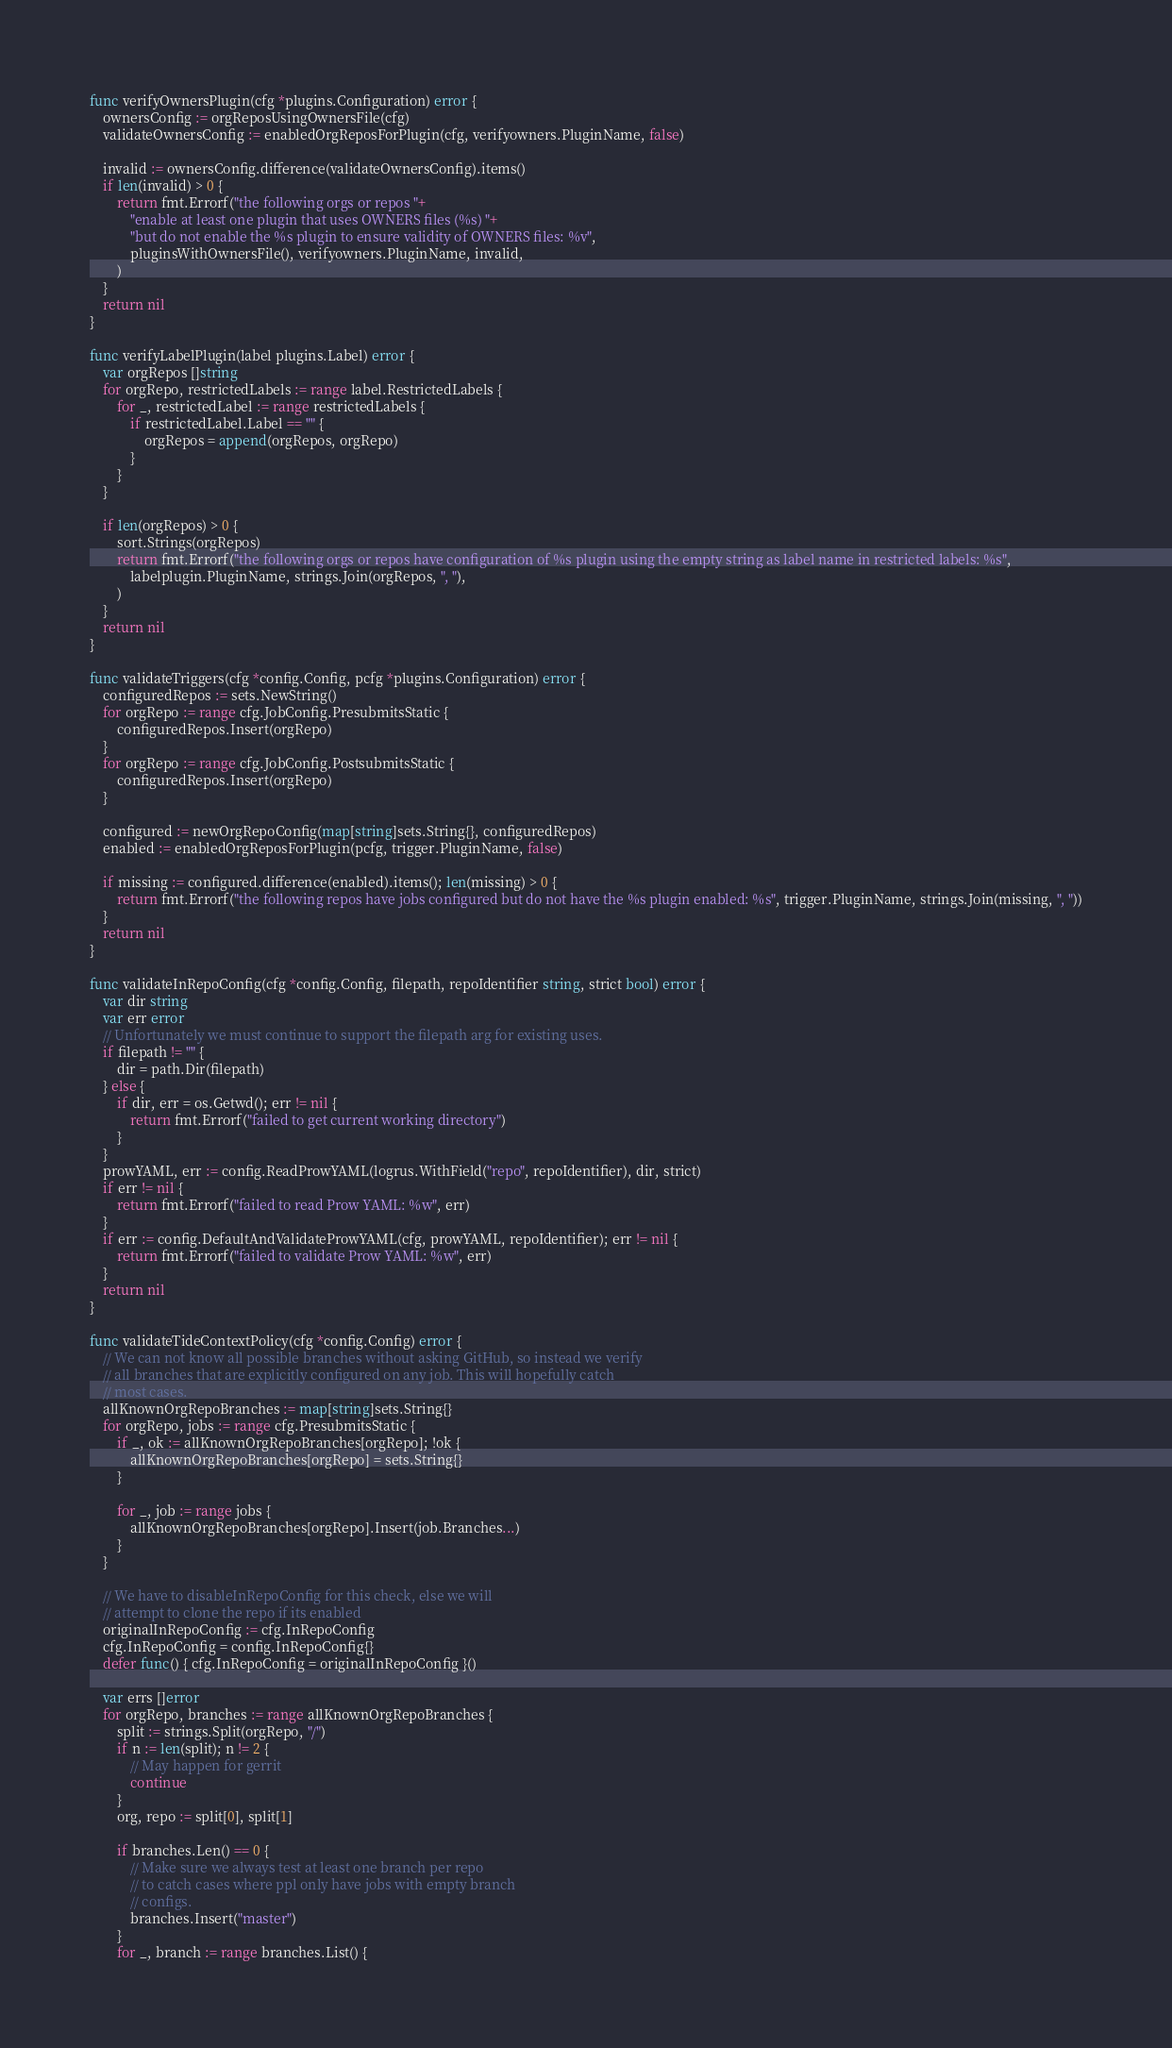<code> <loc_0><loc_0><loc_500><loc_500><_Go_>func verifyOwnersPlugin(cfg *plugins.Configuration) error {
	ownersConfig := orgReposUsingOwnersFile(cfg)
	validateOwnersConfig := enabledOrgReposForPlugin(cfg, verifyowners.PluginName, false)

	invalid := ownersConfig.difference(validateOwnersConfig).items()
	if len(invalid) > 0 {
		return fmt.Errorf("the following orgs or repos "+
			"enable at least one plugin that uses OWNERS files (%s) "+
			"but do not enable the %s plugin to ensure validity of OWNERS files: %v",
			pluginsWithOwnersFile(), verifyowners.PluginName, invalid,
		)
	}
	return nil
}

func verifyLabelPlugin(label plugins.Label) error {
	var orgRepos []string
	for orgRepo, restrictedLabels := range label.RestrictedLabels {
		for _, restrictedLabel := range restrictedLabels {
			if restrictedLabel.Label == "" {
				orgRepos = append(orgRepos, orgRepo)
			}
		}
	}

	if len(orgRepos) > 0 {
		sort.Strings(orgRepos)
		return fmt.Errorf("the following orgs or repos have configuration of %s plugin using the empty string as label name in restricted labels: %s",
			labelplugin.PluginName, strings.Join(orgRepos, ", "),
		)
	}
	return nil
}

func validateTriggers(cfg *config.Config, pcfg *plugins.Configuration) error {
	configuredRepos := sets.NewString()
	for orgRepo := range cfg.JobConfig.PresubmitsStatic {
		configuredRepos.Insert(orgRepo)
	}
	for orgRepo := range cfg.JobConfig.PostsubmitsStatic {
		configuredRepos.Insert(orgRepo)
	}

	configured := newOrgRepoConfig(map[string]sets.String{}, configuredRepos)
	enabled := enabledOrgReposForPlugin(pcfg, trigger.PluginName, false)

	if missing := configured.difference(enabled).items(); len(missing) > 0 {
		return fmt.Errorf("the following repos have jobs configured but do not have the %s plugin enabled: %s", trigger.PluginName, strings.Join(missing, ", "))
	}
	return nil
}

func validateInRepoConfig(cfg *config.Config, filepath, repoIdentifier string, strict bool) error {
	var dir string
	var err error
	// Unfortunately we must continue to support the filepath arg for existing uses.
	if filepath != "" {
		dir = path.Dir(filepath)
	} else {
		if dir, err = os.Getwd(); err != nil {
			return fmt.Errorf("failed to get current working directory")
		}
	}
	prowYAML, err := config.ReadProwYAML(logrus.WithField("repo", repoIdentifier), dir, strict)
	if err != nil {
		return fmt.Errorf("failed to read Prow YAML: %w", err)
	}
	if err := config.DefaultAndValidateProwYAML(cfg, prowYAML, repoIdentifier); err != nil {
		return fmt.Errorf("failed to validate Prow YAML: %w", err)
	}
	return nil
}

func validateTideContextPolicy(cfg *config.Config) error {
	// We can not know all possible branches without asking GitHub, so instead we verify
	// all branches that are explicitly configured on any job. This will hopefully catch
	// most cases.
	allKnownOrgRepoBranches := map[string]sets.String{}
	for orgRepo, jobs := range cfg.PresubmitsStatic {
		if _, ok := allKnownOrgRepoBranches[orgRepo]; !ok {
			allKnownOrgRepoBranches[orgRepo] = sets.String{}
		}

		for _, job := range jobs {
			allKnownOrgRepoBranches[orgRepo].Insert(job.Branches...)
		}
	}

	// We have to disableInRepoConfig for this check, else we will
	// attempt to clone the repo if its enabled
	originalInRepoConfig := cfg.InRepoConfig
	cfg.InRepoConfig = config.InRepoConfig{}
	defer func() { cfg.InRepoConfig = originalInRepoConfig }()

	var errs []error
	for orgRepo, branches := range allKnownOrgRepoBranches {
		split := strings.Split(orgRepo, "/")
		if n := len(split); n != 2 {
			// May happen for gerrit
			continue
		}
		org, repo := split[0], split[1]

		if branches.Len() == 0 {
			// Make sure we always test at least one branch per repo
			// to catch cases where ppl only have jobs with empty branch
			// configs.
			branches.Insert("master")
		}
		for _, branch := range branches.List() {</code> 